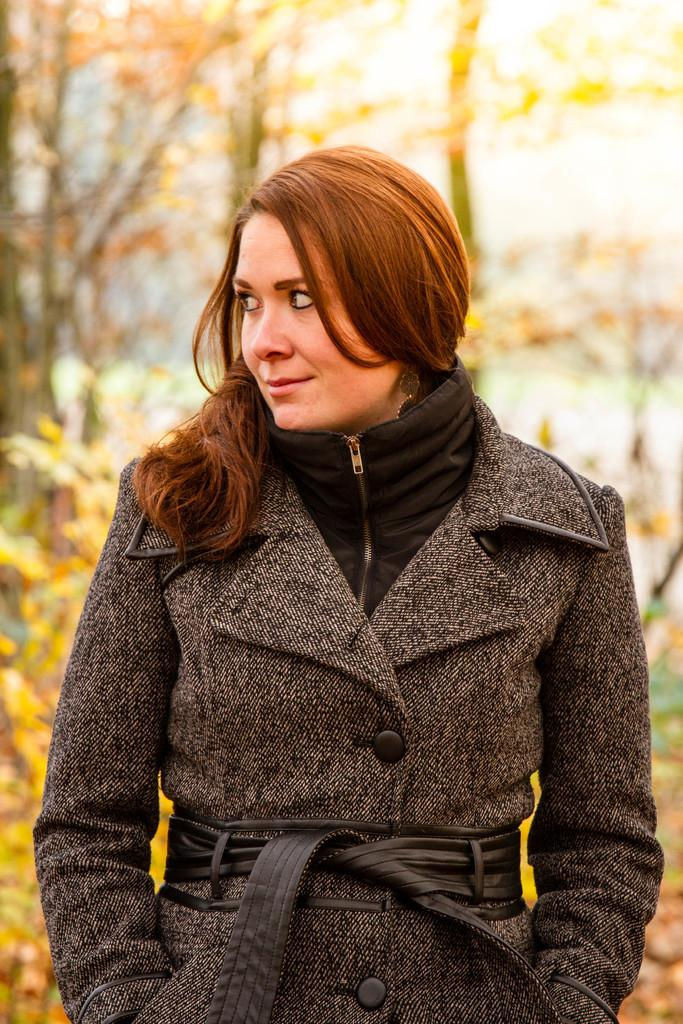Who is present in the image? There is a woman in the image. What is the woman doing in the image? The woman is standing in the image. What expression does the woman have in the image? The woman is smiling in the image. What can be seen in the background of the image? There are trees in the background of the image. How many cats are sitting on the woman's lap in the image? There are no cats present in the image. What advice does the woman's grandfather give her in the image? There is no mention of a grandfather or any advice in the image. 